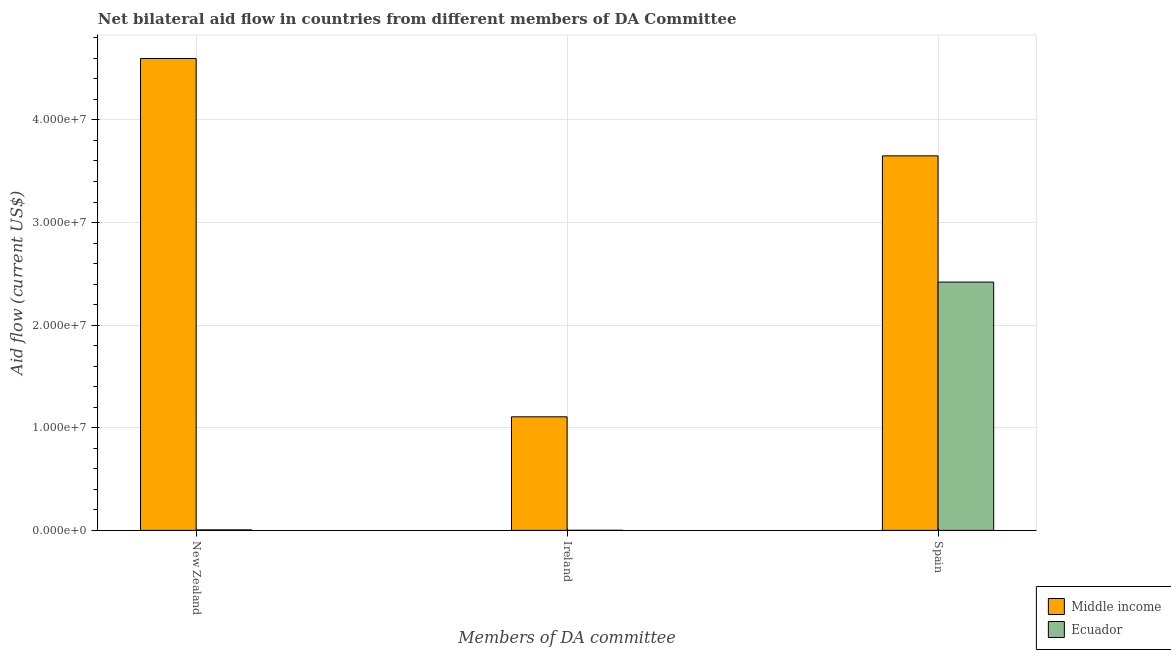How many groups of bars are there?
Give a very brief answer. 3. How many bars are there on the 1st tick from the left?
Provide a short and direct response. 2. What is the label of the 2nd group of bars from the left?
Provide a short and direct response. Ireland. What is the amount of aid provided by new zealand in Ecuador?
Keep it short and to the point. 5.00e+04. Across all countries, what is the maximum amount of aid provided by ireland?
Ensure brevity in your answer.  1.11e+07. Across all countries, what is the minimum amount of aid provided by new zealand?
Provide a short and direct response. 5.00e+04. In which country was the amount of aid provided by new zealand maximum?
Give a very brief answer. Middle income. In which country was the amount of aid provided by new zealand minimum?
Ensure brevity in your answer.  Ecuador. What is the total amount of aid provided by new zealand in the graph?
Keep it short and to the point. 4.60e+07. What is the difference between the amount of aid provided by spain in Ecuador and that in Middle income?
Provide a short and direct response. -1.23e+07. What is the difference between the amount of aid provided by spain in Middle income and the amount of aid provided by new zealand in Ecuador?
Give a very brief answer. 3.64e+07. What is the average amount of aid provided by ireland per country?
Offer a very short reply. 5.54e+06. What is the difference between the amount of aid provided by spain and amount of aid provided by new zealand in Ecuador?
Give a very brief answer. 2.42e+07. In how many countries, is the amount of aid provided by new zealand greater than 8000000 US$?
Offer a terse response. 1. What is the ratio of the amount of aid provided by new zealand in Middle income to that in Ecuador?
Ensure brevity in your answer.  919.8. What is the difference between the highest and the second highest amount of aid provided by new zealand?
Offer a terse response. 4.59e+07. What is the difference between the highest and the lowest amount of aid provided by spain?
Provide a succinct answer. 1.23e+07. In how many countries, is the amount of aid provided by spain greater than the average amount of aid provided by spain taken over all countries?
Make the answer very short. 1. What does the 2nd bar from the left in Ireland represents?
Offer a terse response. Ecuador. What does the 1st bar from the right in New Zealand represents?
Provide a succinct answer. Ecuador. Are all the bars in the graph horizontal?
Provide a short and direct response. No. What is the difference between two consecutive major ticks on the Y-axis?
Provide a succinct answer. 1.00e+07. Does the graph contain any zero values?
Offer a very short reply. No. Does the graph contain grids?
Give a very brief answer. Yes. Where does the legend appear in the graph?
Keep it short and to the point. Bottom right. What is the title of the graph?
Your response must be concise. Net bilateral aid flow in countries from different members of DA Committee. Does "Latin America(developing only)" appear as one of the legend labels in the graph?
Give a very brief answer. No. What is the label or title of the X-axis?
Make the answer very short. Members of DA committee. What is the label or title of the Y-axis?
Provide a succinct answer. Aid flow (current US$). What is the Aid flow (current US$) in Middle income in New Zealand?
Your response must be concise. 4.60e+07. What is the Aid flow (current US$) in Middle income in Ireland?
Offer a very short reply. 1.11e+07. What is the Aid flow (current US$) in Ecuador in Ireland?
Keep it short and to the point. 10000. What is the Aid flow (current US$) in Middle income in Spain?
Give a very brief answer. 3.65e+07. What is the Aid flow (current US$) of Ecuador in Spain?
Make the answer very short. 2.42e+07. Across all Members of DA committee, what is the maximum Aid flow (current US$) in Middle income?
Offer a very short reply. 4.60e+07. Across all Members of DA committee, what is the maximum Aid flow (current US$) in Ecuador?
Offer a terse response. 2.42e+07. Across all Members of DA committee, what is the minimum Aid flow (current US$) of Middle income?
Make the answer very short. 1.11e+07. Across all Members of DA committee, what is the minimum Aid flow (current US$) of Ecuador?
Provide a succinct answer. 10000. What is the total Aid flow (current US$) in Middle income in the graph?
Ensure brevity in your answer.  9.36e+07. What is the total Aid flow (current US$) in Ecuador in the graph?
Make the answer very short. 2.43e+07. What is the difference between the Aid flow (current US$) of Middle income in New Zealand and that in Ireland?
Ensure brevity in your answer.  3.49e+07. What is the difference between the Aid flow (current US$) in Middle income in New Zealand and that in Spain?
Your answer should be compact. 9.49e+06. What is the difference between the Aid flow (current US$) of Ecuador in New Zealand and that in Spain?
Offer a very short reply. -2.42e+07. What is the difference between the Aid flow (current US$) of Middle income in Ireland and that in Spain?
Your answer should be very brief. -2.54e+07. What is the difference between the Aid flow (current US$) of Ecuador in Ireland and that in Spain?
Your answer should be compact. -2.42e+07. What is the difference between the Aid flow (current US$) of Middle income in New Zealand and the Aid flow (current US$) of Ecuador in Ireland?
Your answer should be very brief. 4.60e+07. What is the difference between the Aid flow (current US$) in Middle income in New Zealand and the Aid flow (current US$) in Ecuador in Spain?
Provide a succinct answer. 2.18e+07. What is the difference between the Aid flow (current US$) of Middle income in Ireland and the Aid flow (current US$) of Ecuador in Spain?
Offer a very short reply. -1.31e+07. What is the average Aid flow (current US$) of Middle income per Members of DA committee?
Your answer should be very brief. 3.12e+07. What is the average Aid flow (current US$) in Ecuador per Members of DA committee?
Your response must be concise. 8.09e+06. What is the difference between the Aid flow (current US$) of Middle income and Aid flow (current US$) of Ecuador in New Zealand?
Your answer should be very brief. 4.59e+07. What is the difference between the Aid flow (current US$) in Middle income and Aid flow (current US$) in Ecuador in Ireland?
Provide a short and direct response. 1.11e+07. What is the difference between the Aid flow (current US$) in Middle income and Aid flow (current US$) in Ecuador in Spain?
Provide a short and direct response. 1.23e+07. What is the ratio of the Aid flow (current US$) of Middle income in New Zealand to that in Ireland?
Keep it short and to the point. 4.15. What is the ratio of the Aid flow (current US$) in Ecuador in New Zealand to that in Ireland?
Offer a very short reply. 5. What is the ratio of the Aid flow (current US$) in Middle income in New Zealand to that in Spain?
Your answer should be compact. 1.26. What is the ratio of the Aid flow (current US$) in Ecuador in New Zealand to that in Spain?
Provide a short and direct response. 0. What is the ratio of the Aid flow (current US$) in Middle income in Ireland to that in Spain?
Make the answer very short. 0.3. What is the ratio of the Aid flow (current US$) in Ecuador in Ireland to that in Spain?
Provide a short and direct response. 0. What is the difference between the highest and the second highest Aid flow (current US$) of Middle income?
Offer a very short reply. 9.49e+06. What is the difference between the highest and the second highest Aid flow (current US$) in Ecuador?
Your response must be concise. 2.42e+07. What is the difference between the highest and the lowest Aid flow (current US$) of Middle income?
Offer a terse response. 3.49e+07. What is the difference between the highest and the lowest Aid flow (current US$) in Ecuador?
Make the answer very short. 2.42e+07. 